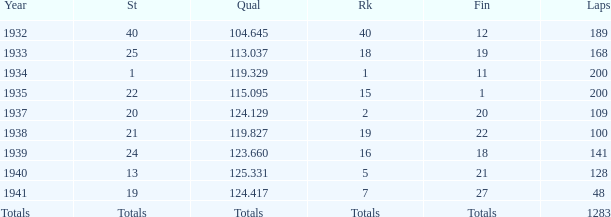What year did he start at 13? 1940.0. 